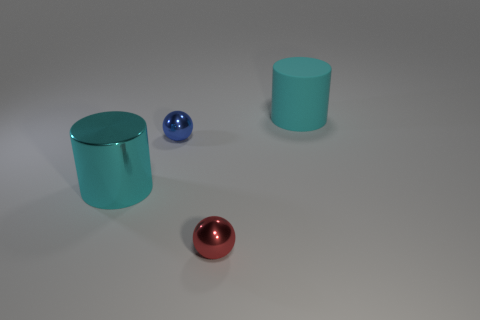Add 4 cyan objects. How many objects exist? 8 Subtract all big gray rubber things. Subtract all red metal things. How many objects are left? 3 Add 3 cyan rubber cylinders. How many cyan rubber cylinders are left? 4 Add 1 big green rubber cylinders. How many big green rubber cylinders exist? 1 Subtract 0 green cubes. How many objects are left? 4 